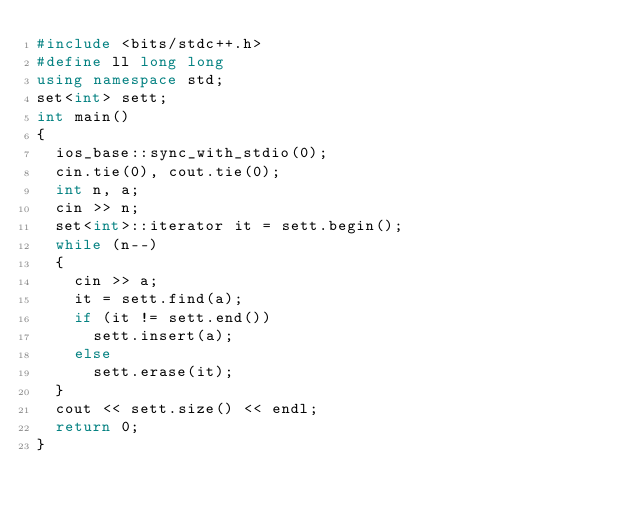Convert code to text. <code><loc_0><loc_0><loc_500><loc_500><_C++_>#include <bits/stdc++.h>
#define ll long long
using namespace std;
set<int> sett;
int main()
{
	ios_base::sync_with_stdio(0);
	cin.tie(0), cout.tie(0);
	int n, a;
	cin >> n;
	set<int>::iterator it = sett.begin();
	while (n--)
	{
		cin >> a;
		it = sett.find(a);
		if (it != sett.end())
			sett.insert(a);
		else
			sett.erase(it);
	}
	cout << sett.size() << endl;
	return 0;
}
</code> 